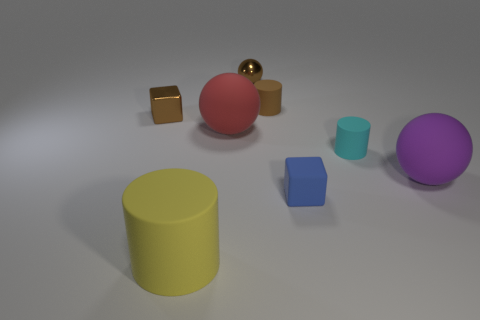Is there a big purple rubber sphere in front of the brown metallic object that is in front of the small metal sphere?
Give a very brief answer. Yes. There is a matte cylinder behind the tiny cyan rubber cylinder; is its color the same as the shiny object that is to the right of the yellow cylinder?
Ensure brevity in your answer.  Yes. There is a cylinder that is the same size as the purple thing; what is its color?
Give a very brief answer. Yellow. Are there an equal number of small brown rubber cylinders in front of the small blue rubber thing and red objects that are in front of the tiny brown metal ball?
Make the answer very short. No. What is the material of the tiny object in front of the purple rubber ball that is behind the blue rubber block?
Keep it short and to the point. Rubber. How many objects are red rubber spheres or big yellow metal spheres?
Your answer should be compact. 1. What is the size of the matte thing that is the same color as the shiny ball?
Offer a very short reply. Small. Are there fewer tiny brown rubber cylinders than large matte things?
Your answer should be compact. Yes. The purple ball that is the same material as the tiny cyan cylinder is what size?
Provide a succinct answer. Large. What is the size of the red sphere?
Give a very brief answer. Large. 